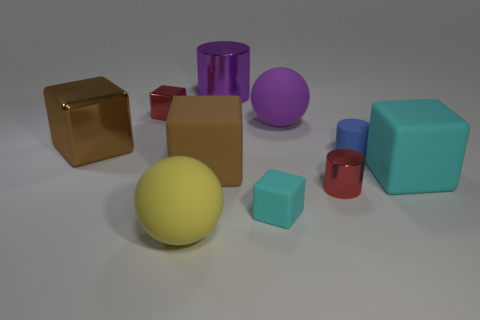Subtract all red blocks. How many blocks are left? 4 Subtract all tiny red metal cubes. How many cubes are left? 4 Subtract all green cubes. Subtract all yellow cylinders. How many cubes are left? 5 Subtract all cylinders. How many objects are left? 7 Subtract all large green metal cubes. Subtract all large purple rubber things. How many objects are left? 9 Add 1 small blocks. How many small blocks are left? 3 Add 6 large yellow rubber balls. How many large yellow rubber balls exist? 7 Subtract 1 red cubes. How many objects are left? 9 